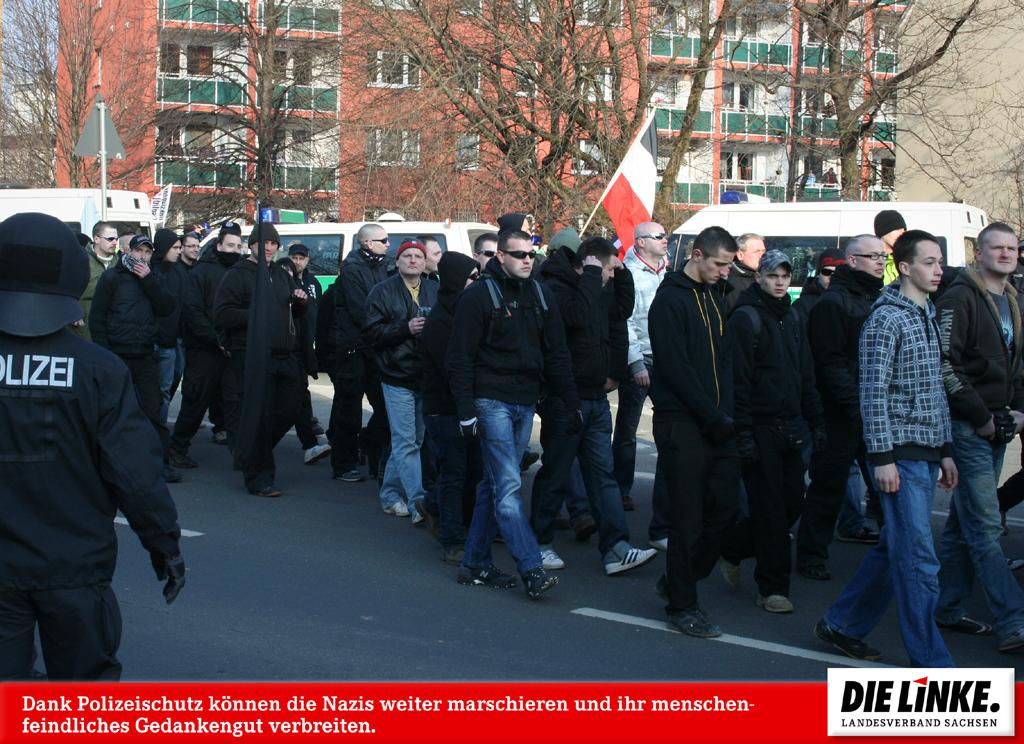What are the men in the foreground of the image doing? The men in the foreground of the image are walking on the road. What are the men holding while walking? The men are holding flags. What can be seen moving in the background of the image? There are vehicles moving in the background of the image. What type of natural elements are visible in the background of the image? There are trees in the background of the image. What type of man-made structures can be seen in the background of the image? There are buildings in the background of the image. Can you tell me the direction in which the parcel is being delivered in the image? There is no parcel present in the image, so it is not possible to determine the direction of delivery. What type of comfort can be seen in the image? The image does not depict any specific type of comfort; it shows men walking on the road, holding flags, and vehicles moving in the background. 